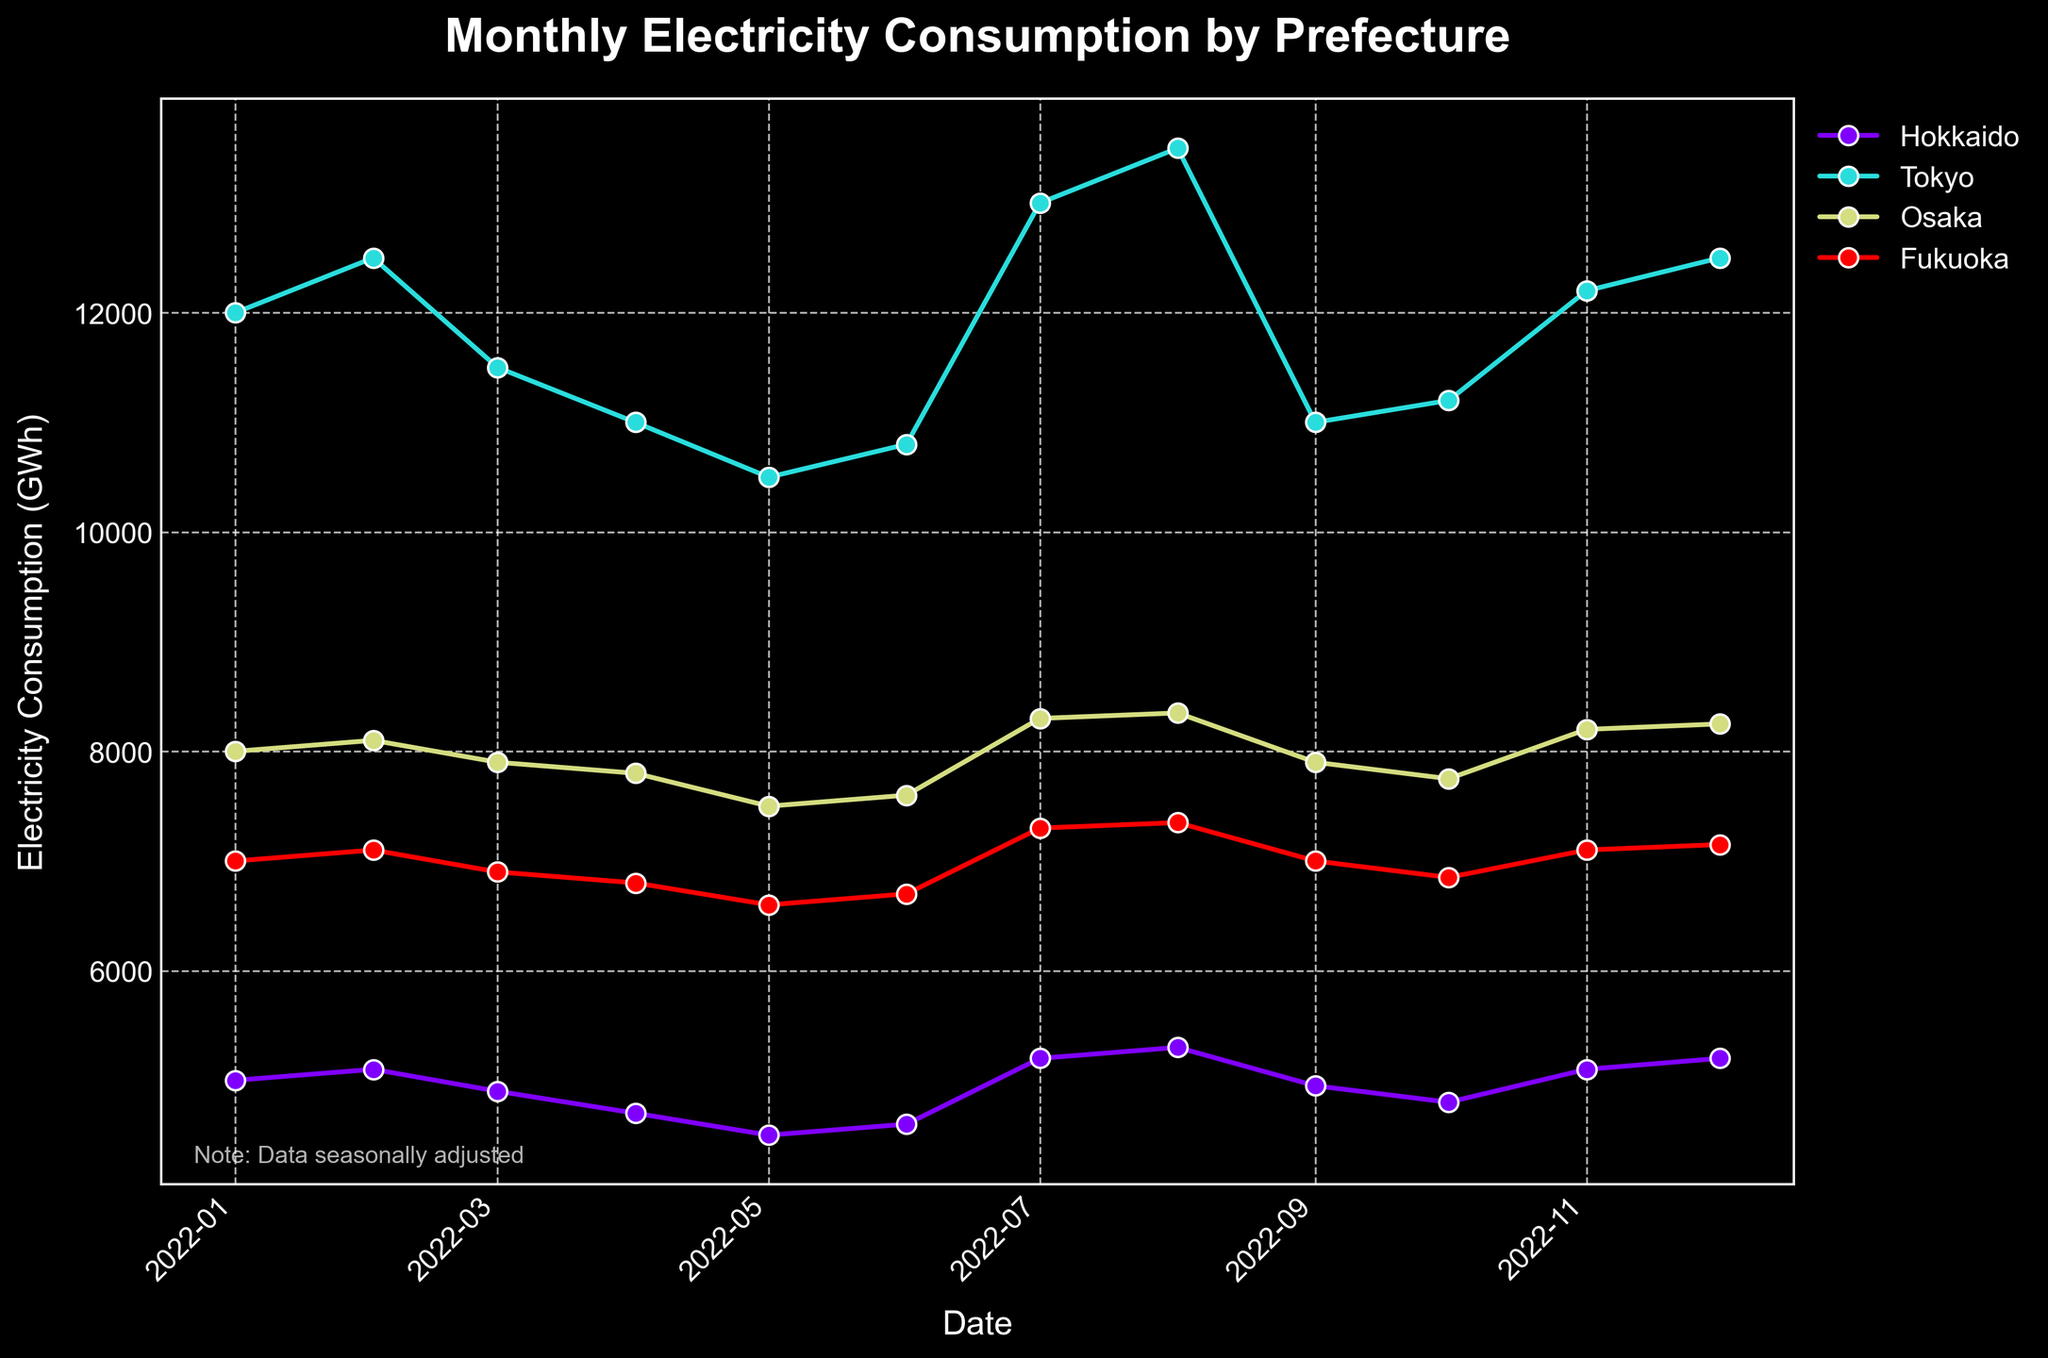What's the title of the figure? The title of the figure is usually located at the top center. In this case, it reads "Monthly Electricity Consumption by Prefecture".
Answer: Monthly Electricity Consumption by Prefecture What is the highest electricity consumption recorded for Tokyo? Observe the series plotted for Tokyo. The peak can be identified by finding the highest point on the graph. For Tokyo, it appears around July or August 2022.
Answer: 13500 GWh Comparing Hokkaido and Osaka, which prefecture has a higher electricity consumption in July 2022? Look at the points on the graph corresponding to July 2022 for both Hokkaido and Osaka. Compare their vertical positions to determine which is higher.
Answer: Osaka Which month shows a dip in electricity consumption for Fukuoka? Scan the graph for Fukuoka's data series, and identify the month where the plot indicates a visible dip.
Answer: March 2022 What is the difference in electricity consumption between January and December 2022 for Hokkaido? Find and compare the points for Hokkaido in January and December 2022. Calculate the difference by deducting the January value from the December value.
Answer: 200 GWh How does the seasonal adjustment mention affect the interpretation of the data? The note about seasonal adjustment implies that observed trends account for seasonal variations, which means the data is adjusted to make it more comparable across months. This helps understand the actual consumption pattern without seasonal effects.
Answer: Data is seasonally adjusted Which prefecture experienced the most fluctuation in monthly electricity consumption over the year? Examine the plot and identify the prefecture with the largest changes in peak-to-trough levels over the months. Calculate or visually estimate the amount of fluctuation.
Answer: Tokyo In which months did Hokkaido's electricity consumption exceed 5000 GWh? Identify all the points for Hokkaido that are above the 5000 GWh line and note their corresponding months.
Answer: January, July, August, December What trend is visible for Tokyo's electricity consumption from January to August 2022? Examine the plot for Tokyo from January to August, noting the general direction the data points follow, whether increasing, decreasing, or fluctuating.
Answer: Increasing Compare the average electricity consumption for Osaka for the first half of the year (January to June) and the second half (July to December). Which half had a higher average? Calculate the average value for each half. Sum the data points for each period (January to June and July to December) and divide each sum by the number of months in the half-year period.
Answer: Second half 